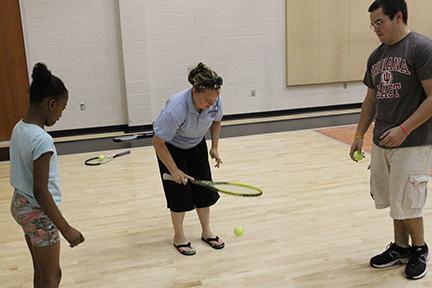How many racquets in the picture?
Give a very brief answer. 3. How many people are in the picture?
Give a very brief answer. 3. How many airplanes do you see?
Give a very brief answer. 0. 